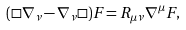Convert formula to latex. <formula><loc_0><loc_0><loc_500><loc_500>( \square \nabla _ { \nu } - \nabla _ { \nu } \square ) F = R _ { \mu \nu } \nabla ^ { \mu } F ,</formula> 